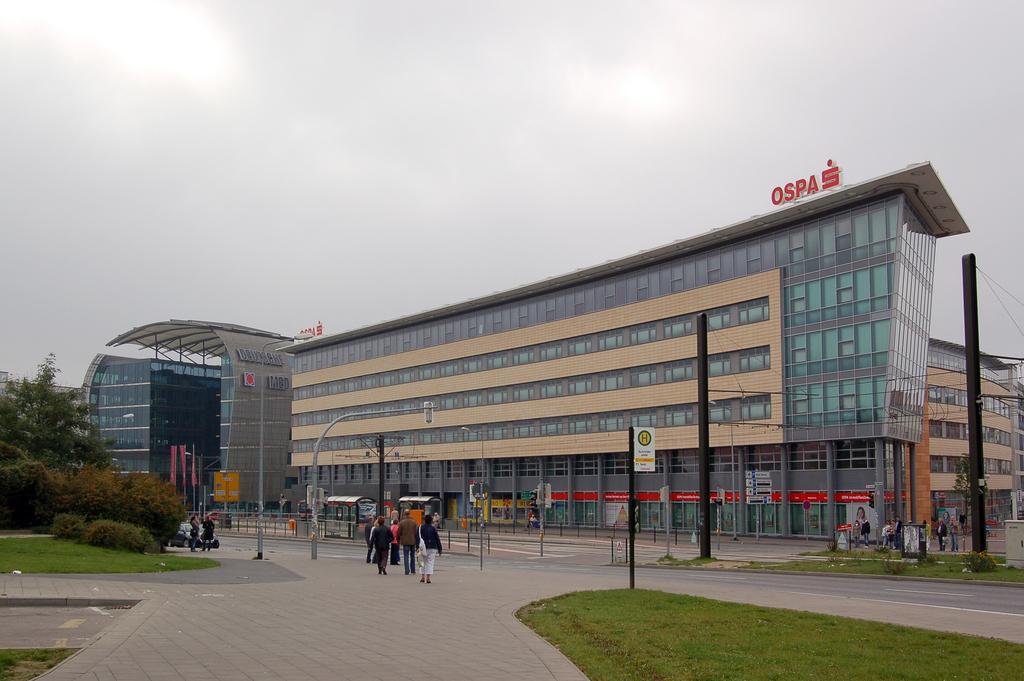Please provide a concise description of this image. At the bottom of the image, we can see people, road, walkways, grass, plants, trees, vehicle and poles. Background we can see buildings, walls, glass objects, boards and sky. 